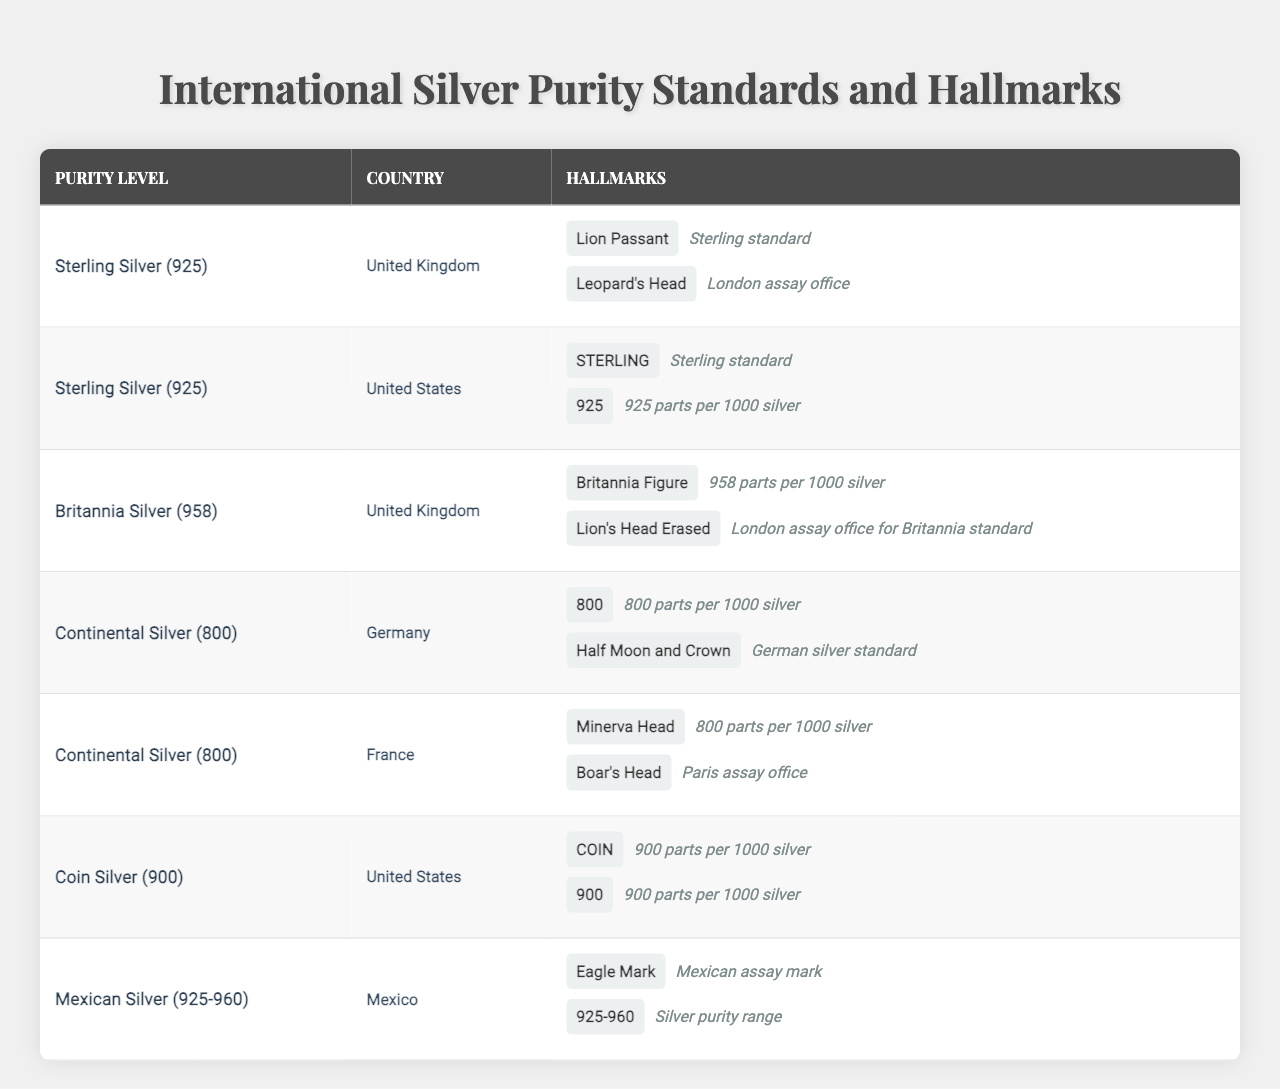What is the hallmark for Sterling Silver in the United Kingdom? For Sterling Silver in the United Kingdom, the hallmark is "Lion Passant," which signifies the sterling standard.
Answer: Lion Passant Which country uses the hallmark "Eagle Mark"? The hallmark "Eagle Mark" is used in Mexico, as indicated in the table under the section for Mexican Silver.
Answer: Mexico What is the purity level associated with the "Britannia Figure"? The "Britannia Figure" hallmark corresponds to the Britannia Silver purity level, which is 958 parts per 1000 silver.
Answer: Britannia Silver (958) Are there any countries that use the hallmark "COIN"? Yes, the hallmark "COIN" is used in the United States, as listed in the table under Coin Silver.
Answer: Yes What is the maximum silver purity level listed in the table? The maximum silver purity level listed in the table is Britannia Silver (958), which has the highest level of silver content compared to others.
Answer: Britannia Silver (958) How many hallmarks are listed for Continental Silver from Germany? There are two hallmarks listed for Continental Silver from Germany: "800" and "Half Moon and Crown."
Answer: 2 Is "925" used as a hallmark in the United States for any silver purity? Yes, "925" is used as a hallmark in the United States for Sterling Silver, confirming the silver content.
Answer: Yes Which assay office is indicated for the hallmark "Lion's Head Erased"? The "Lion's Head Erased" hallmark signifies the London assay office for Britannia standard silver in the United Kingdom.
Answer: London assay office What is the average purity level (in parts per 1000) of silver in the United States based on the table? There are two referenced purity levels for the United States: Sterling Silver (925 parts) and Coin Silver (900 parts). The average is (925 + 900) / 2 = 912.5.
Answer: 912.5 How many different purity levels are represented in this table? The table includes five different purity levels: Sterling Silver, Britannia Silver, Continental Silver, Coin Silver, and Mexican Silver.
Answer: 5 